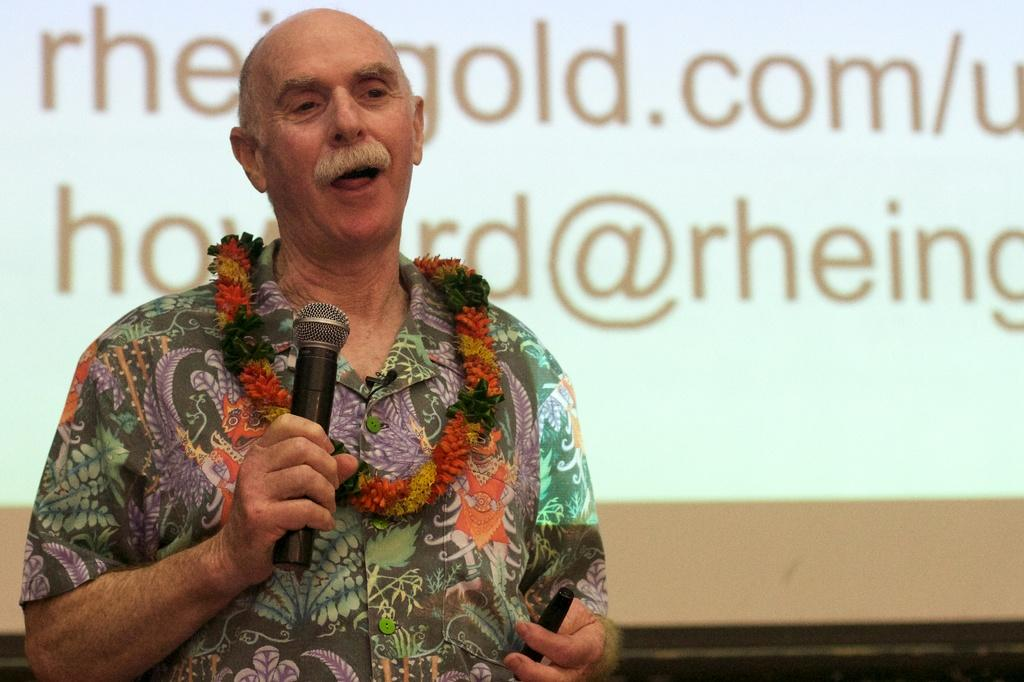Who is present in the image? There is a man in the image. What is the man wearing? The man is wearing a floral shirt. What is the man holding in the image? The man is holding a microphone. What can be seen behind the man in the image? There is a projector screen behind the man. What type of cherries can be seen on the language the man is speaking in the image? There are no cherries or languages mentioned in the image; it only shows a man holding a microphone with a projector screen behind him. 